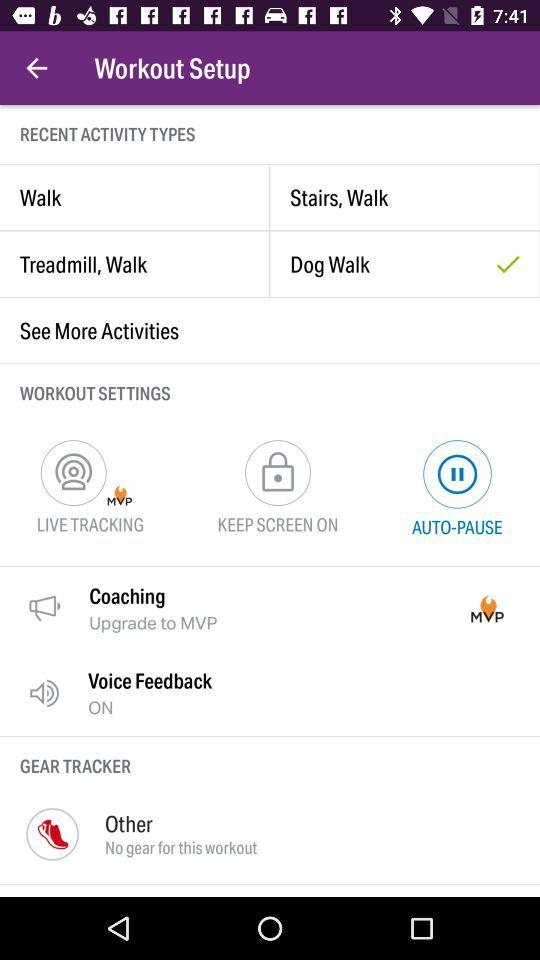Which option is selected in "WORKOUT SETTINGS"? The selected option is "AUTO-PAUSE". 